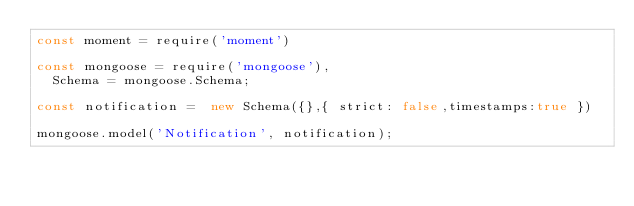<code> <loc_0><loc_0><loc_500><loc_500><_JavaScript_>const moment = require('moment')

const mongoose = require('mongoose'),
  Schema = mongoose.Schema;

const notification =  new Schema({},{ strict: false,timestamps:true })

mongoose.model('Notification', notification);</code> 